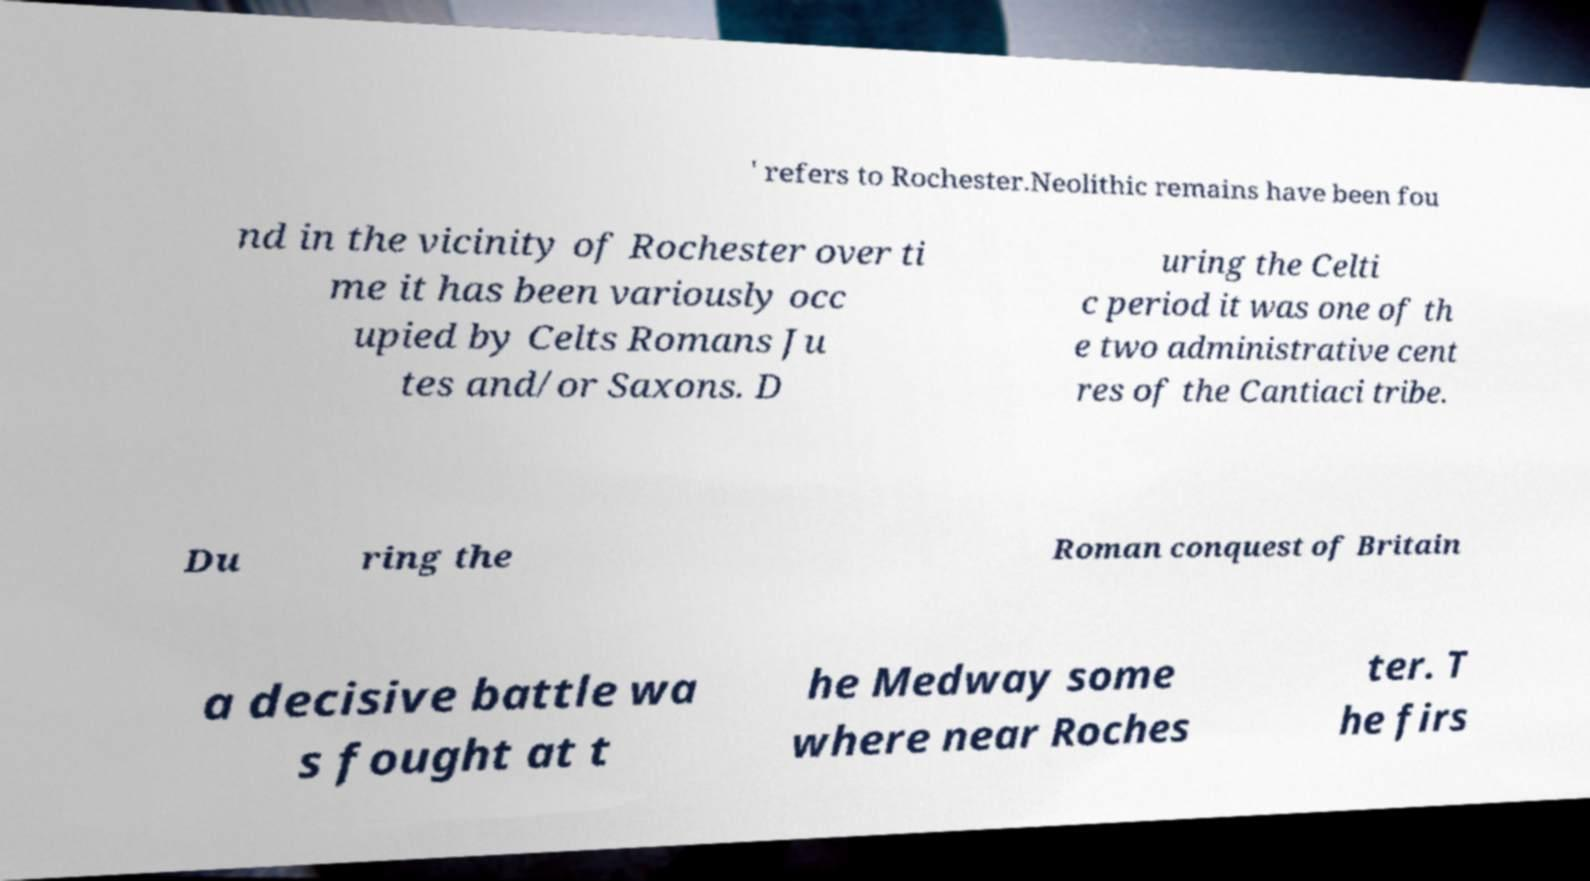Could you assist in decoding the text presented in this image and type it out clearly? ' refers to Rochester.Neolithic remains have been fou nd in the vicinity of Rochester over ti me it has been variously occ upied by Celts Romans Ju tes and/or Saxons. D uring the Celti c period it was one of th e two administrative cent res of the Cantiaci tribe. Du ring the Roman conquest of Britain a decisive battle wa s fought at t he Medway some where near Roches ter. T he firs 